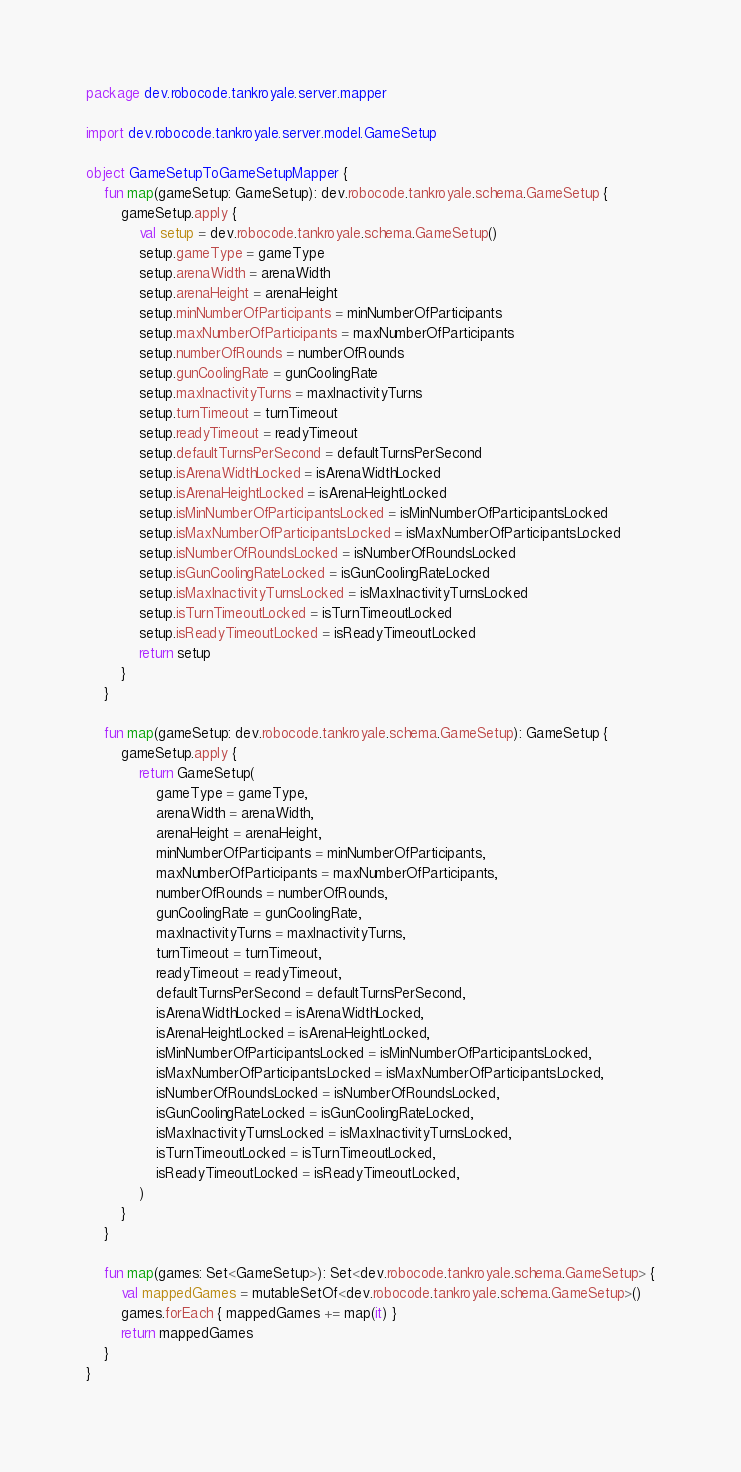<code> <loc_0><loc_0><loc_500><loc_500><_Kotlin_>package dev.robocode.tankroyale.server.mapper

import dev.robocode.tankroyale.server.model.GameSetup

object GameSetupToGameSetupMapper {
    fun map(gameSetup: GameSetup): dev.robocode.tankroyale.schema.GameSetup {
        gameSetup.apply {
            val setup = dev.robocode.tankroyale.schema.GameSetup()
            setup.gameType = gameType
            setup.arenaWidth = arenaWidth
            setup.arenaHeight = arenaHeight
            setup.minNumberOfParticipants = minNumberOfParticipants
            setup.maxNumberOfParticipants = maxNumberOfParticipants
            setup.numberOfRounds = numberOfRounds
            setup.gunCoolingRate = gunCoolingRate
            setup.maxInactivityTurns = maxInactivityTurns
            setup.turnTimeout = turnTimeout
            setup.readyTimeout = readyTimeout
            setup.defaultTurnsPerSecond = defaultTurnsPerSecond
            setup.isArenaWidthLocked = isArenaWidthLocked
            setup.isArenaHeightLocked = isArenaHeightLocked
            setup.isMinNumberOfParticipantsLocked = isMinNumberOfParticipantsLocked
            setup.isMaxNumberOfParticipantsLocked = isMaxNumberOfParticipantsLocked
            setup.isNumberOfRoundsLocked = isNumberOfRoundsLocked
            setup.isGunCoolingRateLocked = isGunCoolingRateLocked
            setup.isMaxInactivityTurnsLocked = isMaxInactivityTurnsLocked
            setup.isTurnTimeoutLocked = isTurnTimeoutLocked
            setup.isReadyTimeoutLocked = isReadyTimeoutLocked
            return setup
        }
    }

    fun map(gameSetup: dev.robocode.tankroyale.schema.GameSetup): GameSetup {
        gameSetup.apply {
            return GameSetup(
                gameType = gameType,
                arenaWidth = arenaWidth,
                arenaHeight = arenaHeight,
                minNumberOfParticipants = minNumberOfParticipants,
                maxNumberOfParticipants = maxNumberOfParticipants,
                numberOfRounds = numberOfRounds,
                gunCoolingRate = gunCoolingRate,
                maxInactivityTurns = maxInactivityTurns,
                turnTimeout = turnTimeout,
                readyTimeout = readyTimeout,
                defaultTurnsPerSecond = defaultTurnsPerSecond,
                isArenaWidthLocked = isArenaWidthLocked,
                isArenaHeightLocked = isArenaHeightLocked,
                isMinNumberOfParticipantsLocked = isMinNumberOfParticipantsLocked,
                isMaxNumberOfParticipantsLocked = isMaxNumberOfParticipantsLocked,
                isNumberOfRoundsLocked = isNumberOfRoundsLocked,
                isGunCoolingRateLocked = isGunCoolingRateLocked,
                isMaxInactivityTurnsLocked = isMaxInactivityTurnsLocked,
                isTurnTimeoutLocked = isTurnTimeoutLocked,
                isReadyTimeoutLocked = isReadyTimeoutLocked,
            )
        }
    }

    fun map(games: Set<GameSetup>): Set<dev.robocode.tankroyale.schema.GameSetup> {
        val mappedGames = mutableSetOf<dev.robocode.tankroyale.schema.GameSetup>()
        games.forEach { mappedGames += map(it) }
        return mappedGames
    }
}</code> 